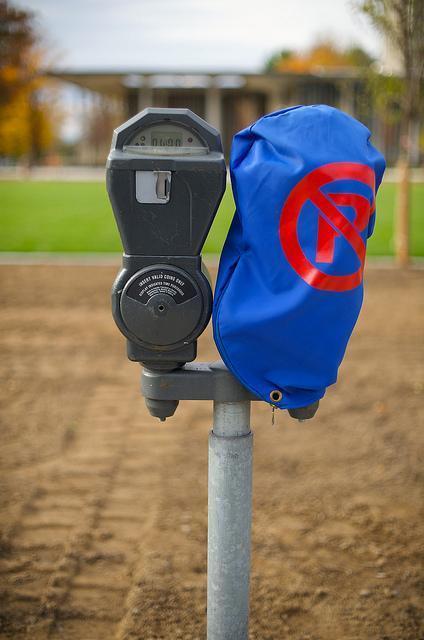How many parking spots are along this curb?
Give a very brief answer. 1. How many parking meters are there?
Give a very brief answer. 2. How many of the baskets of food have forks in them?
Give a very brief answer. 0. 